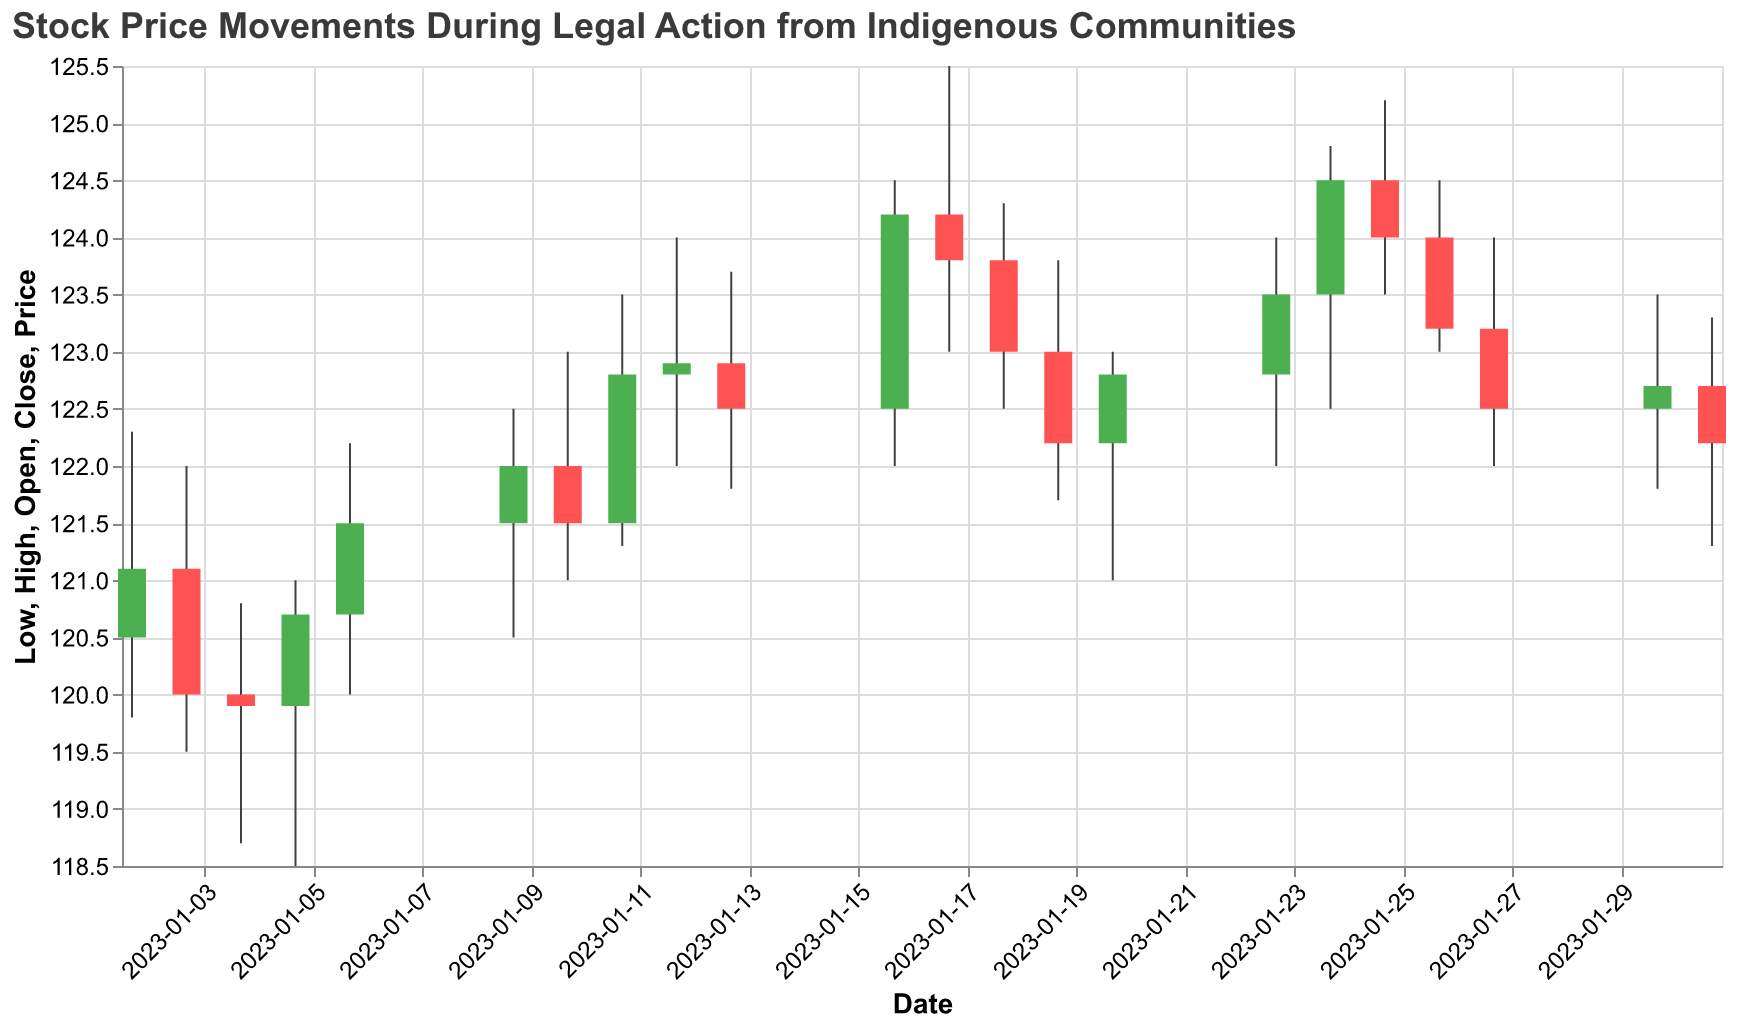What's the title of the figure? The title of the figure is displayed at the top, summarizing the main theme of the chart.
Answer: Stock Price Movements During Legal Action from Indigenous Communities How did the stock price close on the date the lawsuit was filed? Look at the candlestick for January 2, 2023, and find the "Close" value. The closing price is the top or bottom of the solid part of the candlestick if it is green or red respectively.
Answer: 121.10 What was the stock price's highest value during the preliminary hearing day, and what was the lowest? Look at the candlestick for January 10, 2023, and check the highest and lowest points of the wick.
Answer: Highest: 123.00, Lowest: 121.00 How did the stock price change during the community protests on January 16, 2023? Check the "Open" and "Close" values for the candlestick on January 16, 2023. Subtract the opening value from the closing value if it is green (positive change) or vice versa if it is red (negative change).
Answer: Increase of 1.70 (from 122.50 to 124.20) Which date shows a significant drop in stock price following the event and what was the event? Identify the dates with significant price drops by comparing their "Open" and "Close" values accompanied by the events tagged next to them.
Answer: January 31, 2023; Judgment in Favor of Community How many days after the ruling announcement did the stock price close below its open? Look at the dates following January 23, 2023, and count the days where the closing price was less than the opening price until the next upward closing day.
Answer: 2 days (January 25, 26) On which date did the stock experience the highest daily trading volume, and how much was it? Review the volume values in the dataset and identify the highest volume, then match it to the corresponding date.
Answer: January 5, 2023, with a volume of 1,800,000 Compare the stock's closing price on the day of the ruling announcement with the closing price on the next trading day. Which was higher? Compare the closing value on January 23, 2023, with that on January 24, 2023.
Answer: January 24, 2023 (124.50) was higher than January 23, 2023 (123.50) What overall trend can be observed in stock prices between the dates the lawsuit was filed and the judgment was made? Examine the "Open" and "Close" prices at major events: January 2, 2023 (Lawsuit Filed) and January 31, 2023 (Judgment). Calculate the difference between the beginning and end prices to determine overall movement direction.
Answer: Overall decrease (from 121.10 to 122.20) How did the stock react on the next trading day after community protests compared to the day of the protests itself? Compare the closing prices of January 16, 2023 (Community Protests), and January 17, 2023, and determine the change.
Answer: The stock decreased from 124.20 to 123.80 (a decrease of 0.40) 